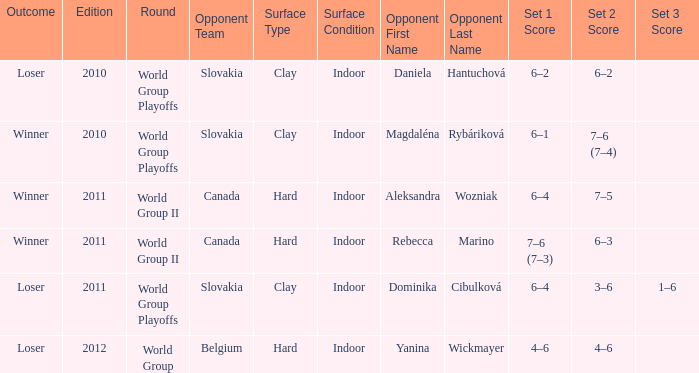What was the result when the adversary was dominika cibulková? 6–4, 3–6, 1–6. 